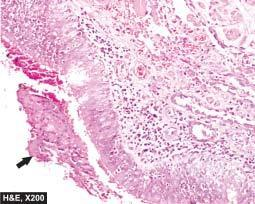s the bronchial wall thickened and infiltrated by acute and chronic inflammatory cells?
Answer the question using a single word or phrase. Yes 